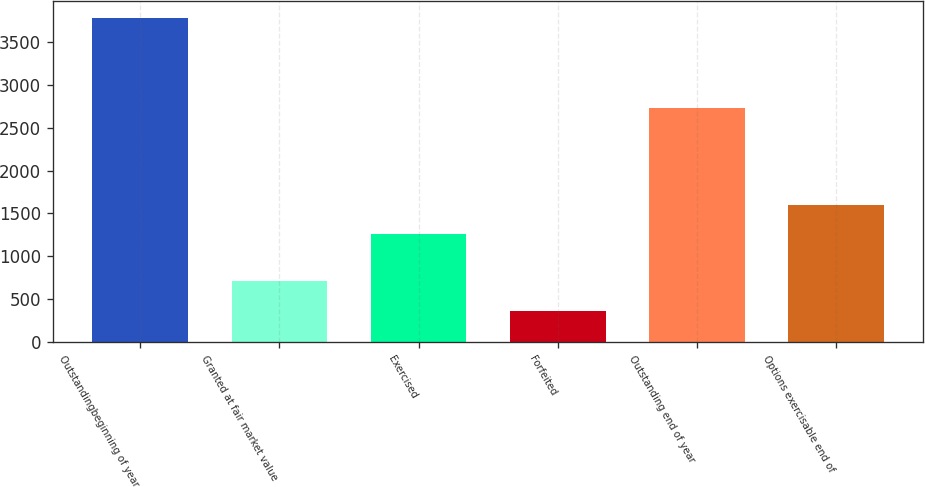Convert chart to OTSL. <chart><loc_0><loc_0><loc_500><loc_500><bar_chart><fcel>Outstandingbeginning of year<fcel>Granted at fair market value<fcel>Exercised<fcel>Forfeited<fcel>Outstanding end of year<fcel>Options exercisable end of<nl><fcel>3782<fcel>708.5<fcel>1262<fcel>367<fcel>2732<fcel>1603.5<nl></chart> 